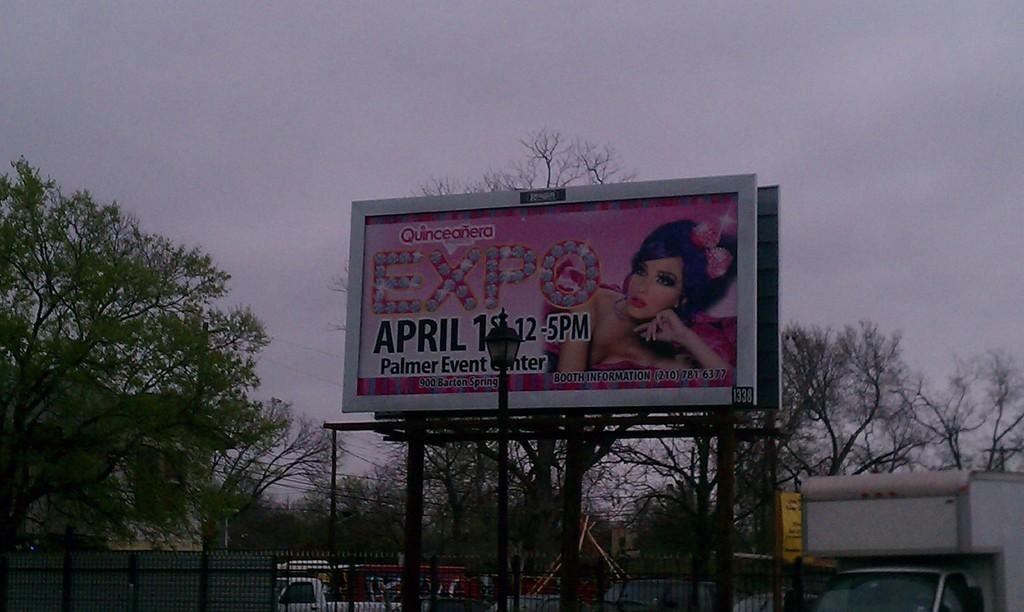<image>
Render a clear and concise summary of the photo. A roadside sign advertises an Expo at the Palmer Event Center. 